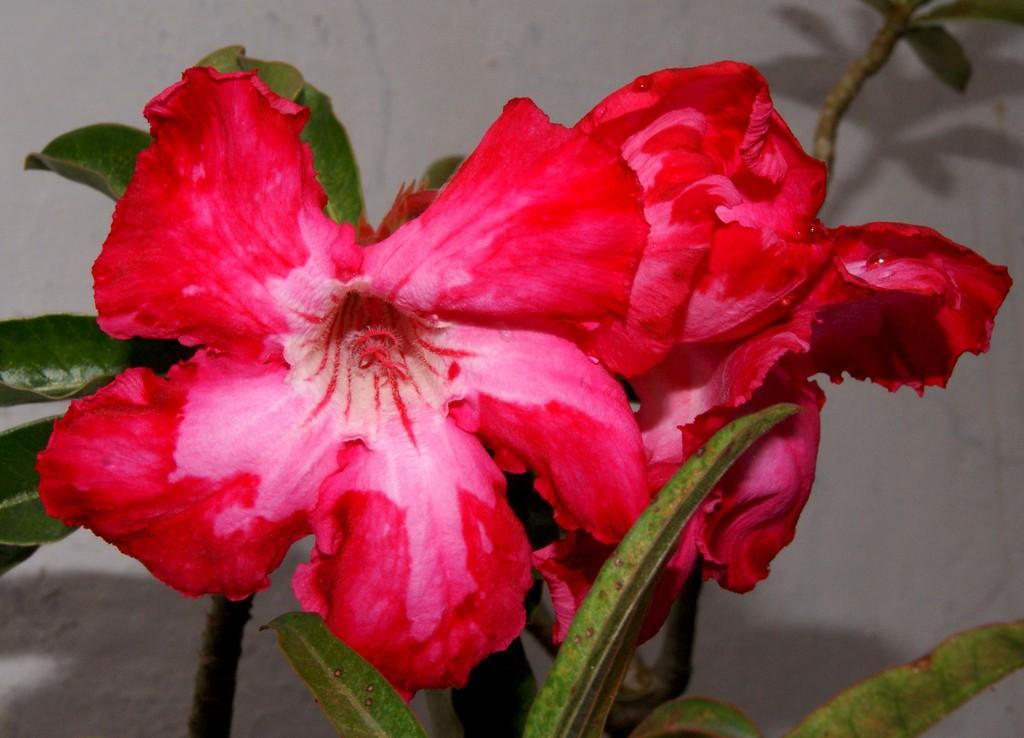What type of flowers can be seen in the image? There are red color flowers in the image. What is the color of the wall in the background of the image? The wall in the background of the image is white color. What is the limit of the net in the image? There is no net present in the image. What items are on the list in the image? There is no list present in the image. 